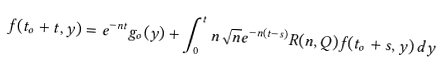Convert formula to latex. <formula><loc_0><loc_0><loc_500><loc_500>f ( t _ { o } + t , y ) = e ^ { - n t } g _ { o } ( y ) + \int _ { 0 } ^ { t } n \sqrt { n } e ^ { - n ( t - s ) } R ( n , Q ) f ( t _ { o } + s , y ) \, d y</formula> 